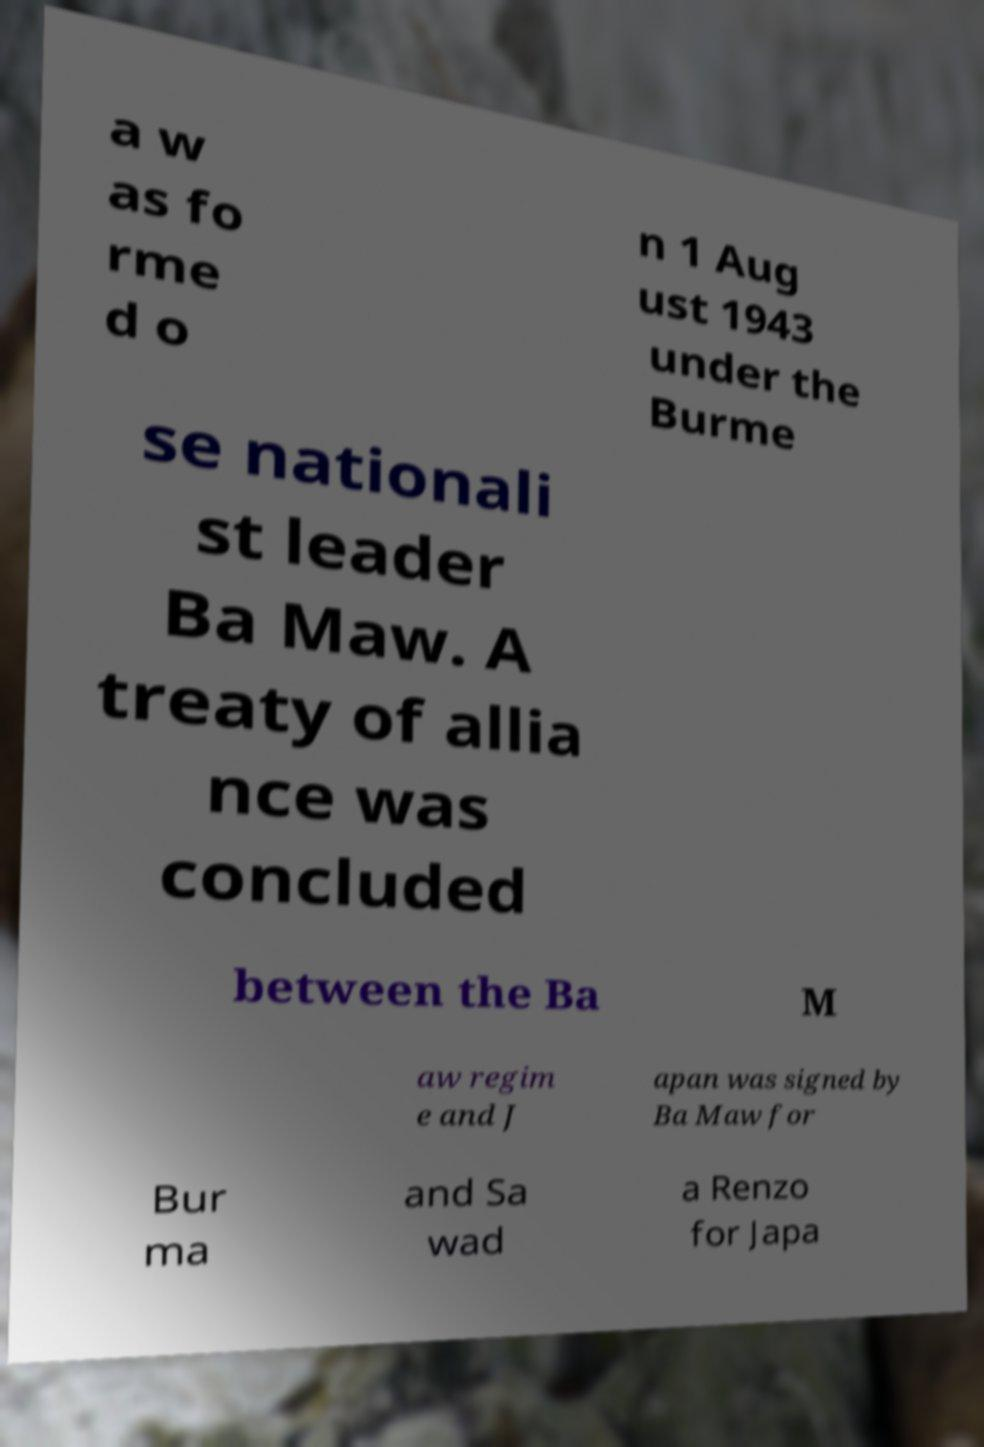What messages or text are displayed in this image? I need them in a readable, typed format. a w as fo rme d o n 1 Aug ust 1943 under the Burme se nationali st leader Ba Maw. A treaty of allia nce was concluded between the Ba M aw regim e and J apan was signed by Ba Maw for Bur ma and Sa wad a Renzo for Japa 